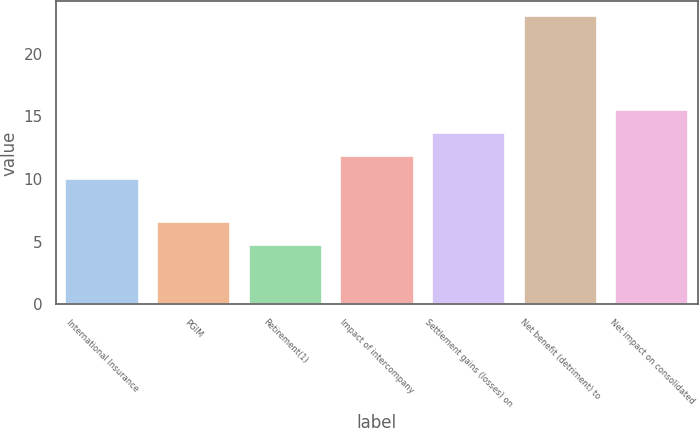<chart> <loc_0><loc_0><loc_500><loc_500><bar_chart><fcel>International Insurance<fcel>PGIM<fcel>Retirement(1)<fcel>Impact of intercompany<fcel>Settlement gains (losses) on<fcel>Net benefit (detriment) to<fcel>Net impact on consolidated<nl><fcel>10<fcel>6.55<fcel>4.72<fcel>11.83<fcel>13.66<fcel>23<fcel>15.49<nl></chart> 